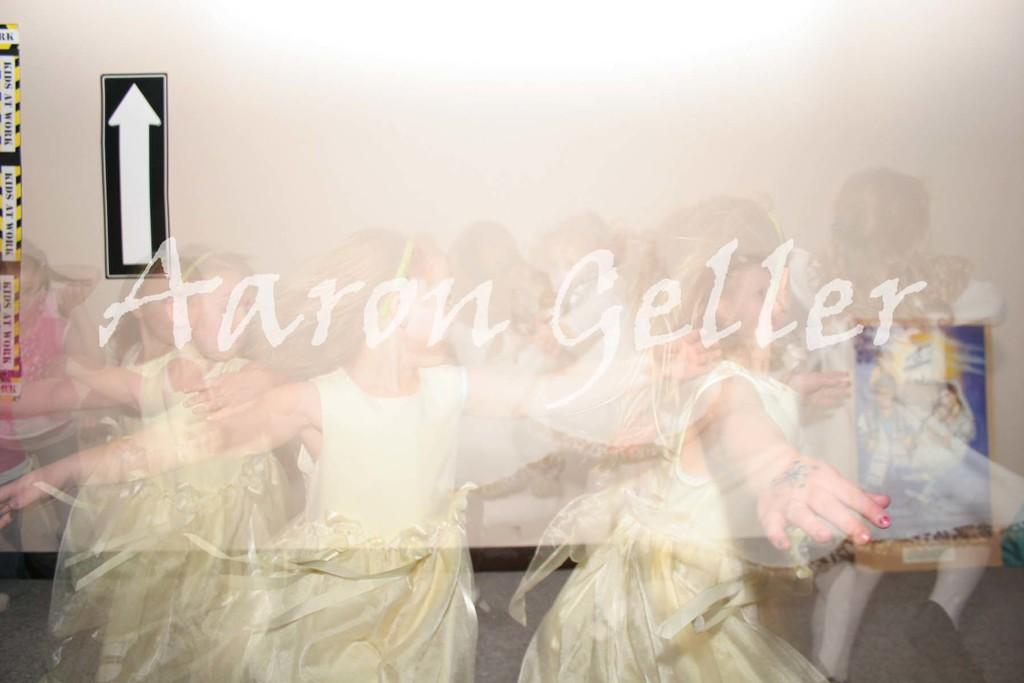How has the image been altered? The image is edited. What can be found in the center of the image? There is text in the center of the image. Who is present in the image? There are girls in the image. What is visible in the background of the image? There is a wall in the background of the image. What else can be seen in the image? There is a sign in the image. Can you see any scissors cutting the cheese on the slope in the image? There are no scissors, cheese, or slope present in the image. 